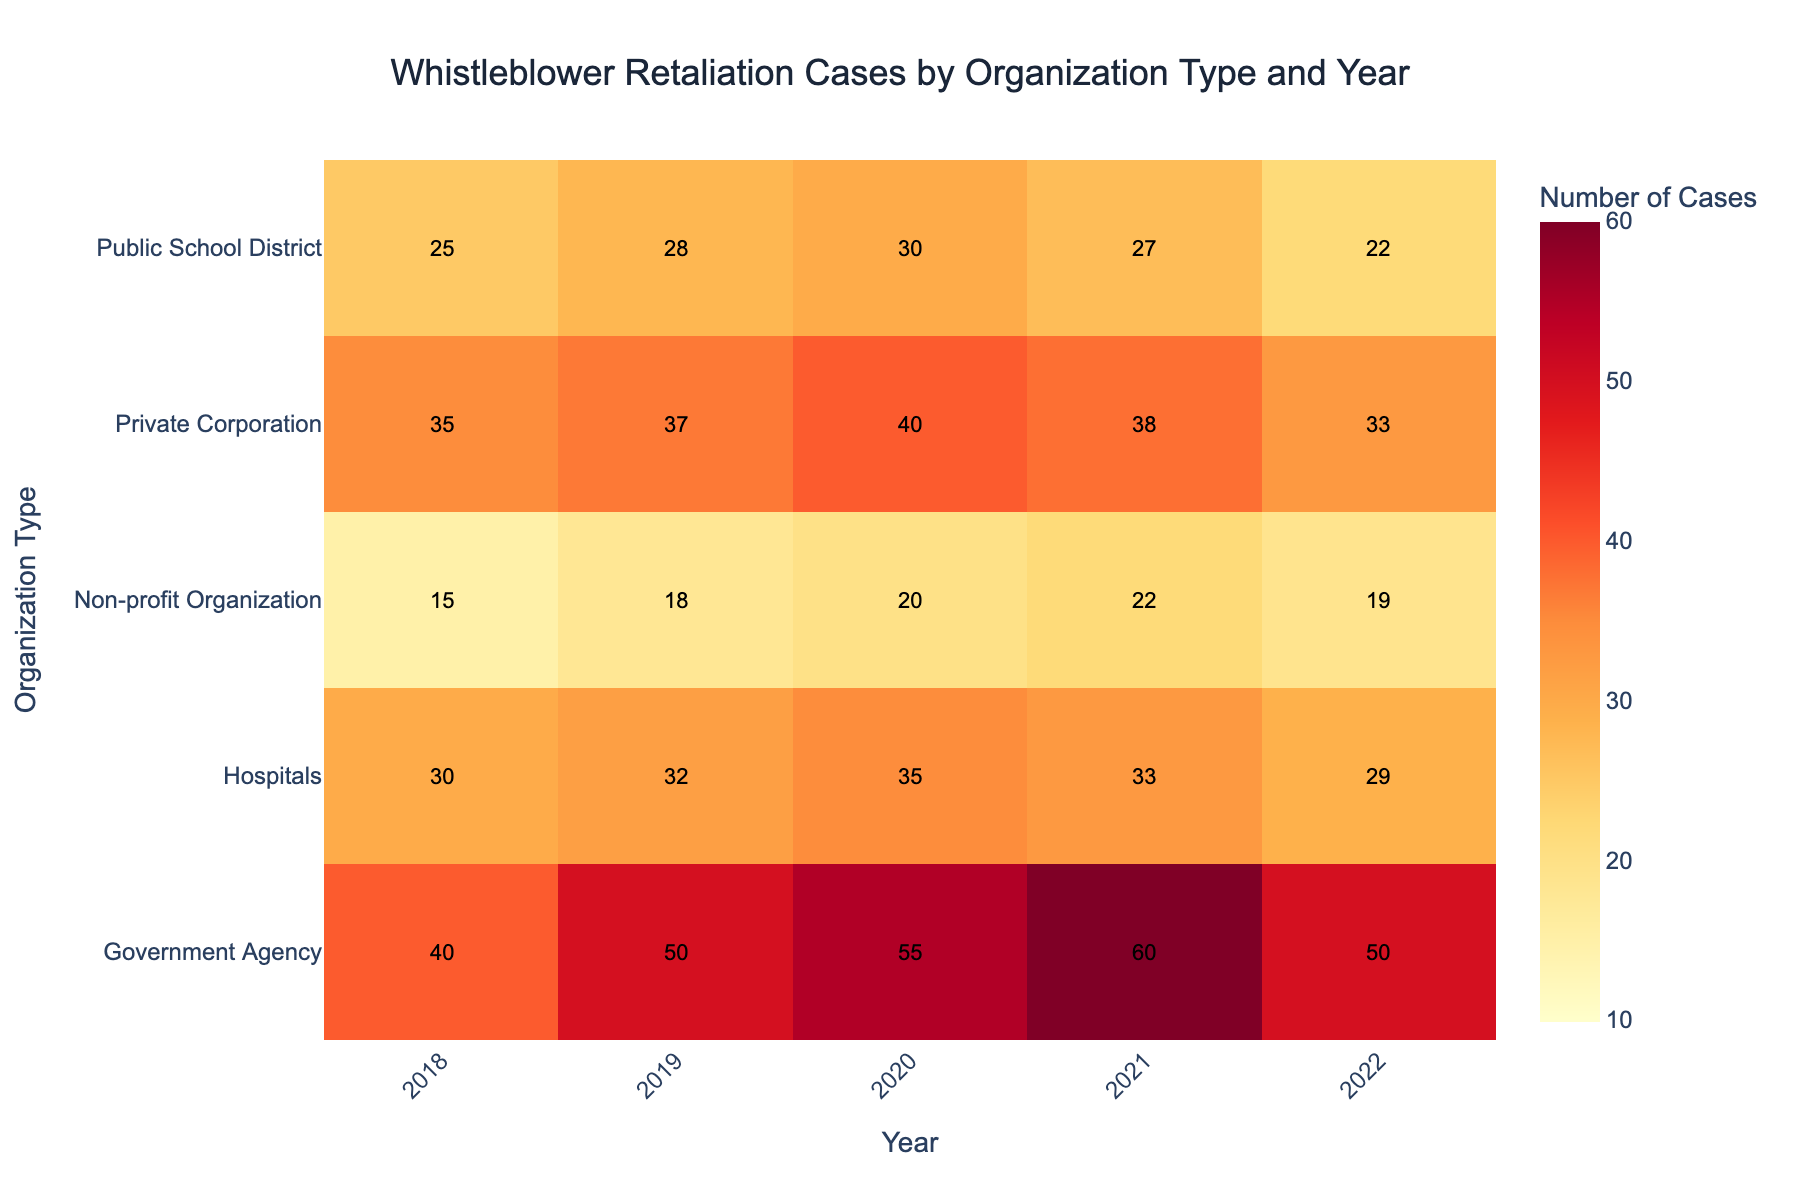Which year had the highest number of whistleblower retaliation cases in Government Agencies? To find the year with the highest number of cases in Government Agencies, look at the numbers in the corresponding row for each year. The highest value in the row for Government Agencies is 60, which occurs in 2021.
Answer: 2021 What is the overall trend in the number of whistleblower retaliation cases in Non-profit Organizations from 2018 to 2022? Check the values for Non-profit Organizations in each year from 2018 to 2022. The values are 15, 18, 20, 22, and 19. This shows a rising trend from 2018 to 2021, peaking in 2021, and then a slight decrease in 2022.
Answer: Rising then slight decrease How many more cases were there in Hospitals in 2020 compared to 2019? Look at the values for Hospitals in 2019 and 2020, which are 32 and 35 respectively. Subtract the first value from the second: 35 - 32 = 3.
Answer: 3 Which organization type had the lowest number of cases in 2022? Look at the values for each organization type for the year 2022. The lowest value (19) is for Non-profit Organizations.
Answer: Non-profit Organizations What is the sum of whistleblower retaliation cases in Private Corporations across all years? Sum up the values for Private Corporations across all years: 35 (2018) + 37 (2019) + 40 (2020) + 38 (2021) + 33 (2022). The total is 183.
Answer: 183 In which year did Public School Districts see a decrease in the number of cases compared to the previous year? Compare the values for each year for Public School Districts to see where there is a decrease. From 2019 to 2020, the values went from 28 to 30 (increase). From 2020 to 2021, the values went from 30 to 27 (decrease).
Answer: 2021 How does the number of cases in Government Agencies in 2018 compare to that in 2021? Compare the values for Government Agencies in 2018 and 2021, which are 40 and 60 respectively. There are 20 more cases in 2021 compared to 2018.
Answer: 20 more in 2021 Which organization type showed a consistent increase in the number of cases every year from 2018 to 2021? Check each organization type's yearly numbers to see if the values increase each year. Government Agencies have increasing values every year from 2018 (40), 2019 (50), 2020 (55), and 2021 (60).
Answer: Government Agencies What is the average number of cases across all organization types in 2022? Sum the values for all organization types in 2022 and divide by the number of types: (22 + 29 + 50 + 33 + 19) / 5 = 30.6.
Answer: 30.6 